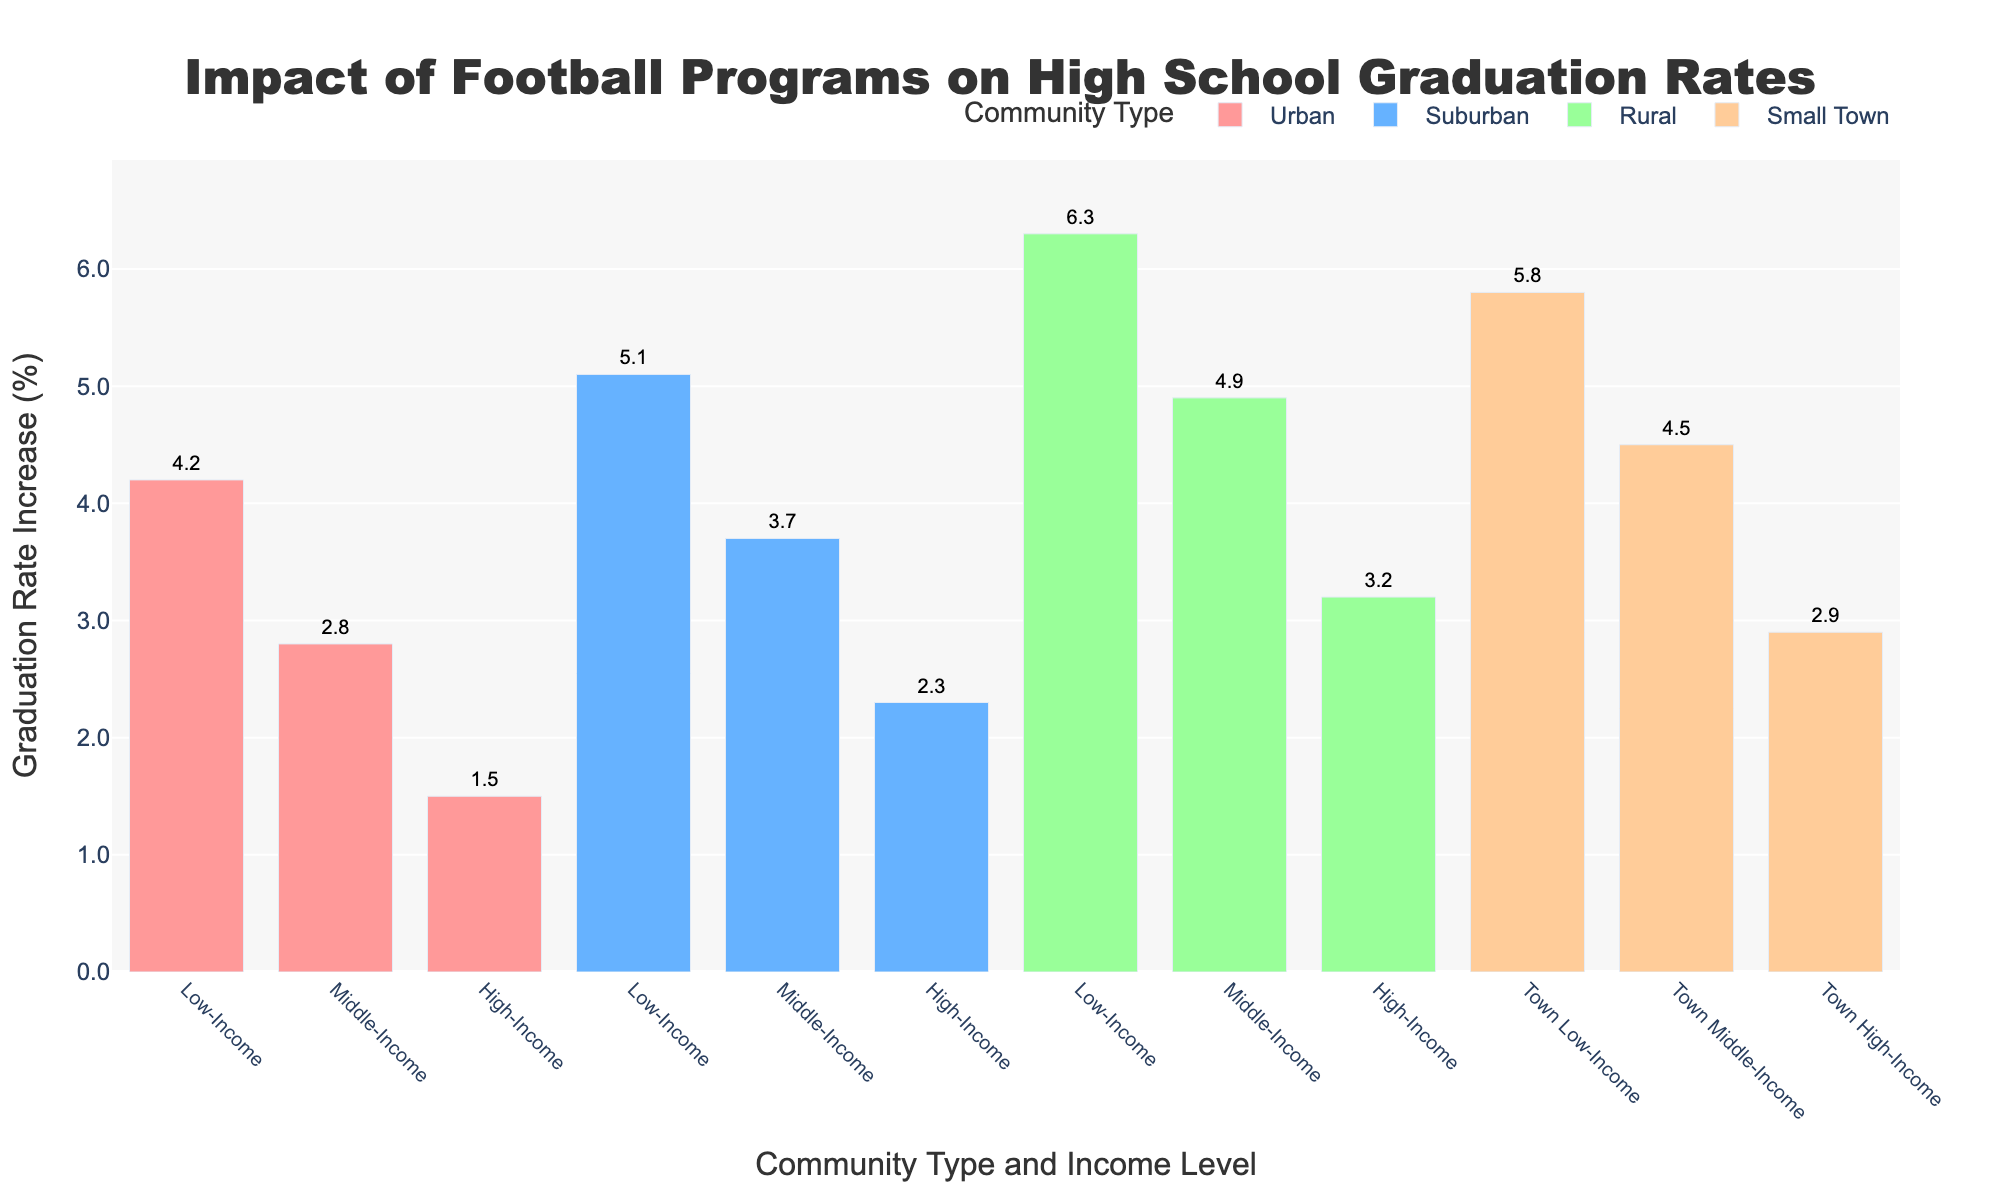Which community type has the highest increase in graduation rates for low-income groups? To determine the highest increase, look at the bar heights for "Low-Income" across all community types. The bar for "Rural Low-Income" is the tallest among the low-income groups.
Answer: Rural What's the difference in graduation rate increase between "Urban Low-Income" and "Urban High-Income" communities? Identify the bars for "Urban Low-Income" and "Urban High-Income". Subtract the graduation rate increase of "Urban High-Income" (1.5%) from "Urban Low-Income" (4.2%). 4.2% - 1.5% = 2.7%.
Answer: 2.7% Among "Rural", "Suburban", and "Urban" middle-income communities, which has the smallest graduation rate increase? Compare the bars for "Middle-Income" in "Rural," "Suburban," and "Urban". "Urban Middle-Income" has the smallest increase (2.8%).
Answer: Urban Middle-Income What is the average graduation rate increase for all communities classified as "High-Income"? Add the graduation rate increases for all "High-Income" communities: Urban (1.5%), Suburban (2.3%), Rural (3.2%), Small Town (2.9%). Divide by the number of high-income communities (4). 
(1.5% + 2.3% + 3.2% + 2.9%) / 4 = 9.9% / 4 = 2.475%.
Answer: 2.5% Does the "Small Town Low-Income" have a higher graduation rate increase than "Suburban Middle-Income"? Compare the bars for "Small Town Low-Income" (5.8%) and "Suburban Middle-Income" (3.7%). Small Town Low-Income is higher.
Answer: Yes Which community type, regardless of income, generally shows the highest graduation rate increase? Compare the heights of the bars across all community types. "Rural" community bars generally show the highest graduation rate increases.
Answer: Rural What is the total graduation rate increase for all "Low-Income" communities combined? Add the graduation rate increases for all "Low-Income" communities: Urban (4.2%), Suburban (5.1%), Rural (6.3%), Small Town (5.8%).
4.2% + 5.1% + 6.3% + 5.8% = 21.4%.
Answer: 21.4% Which bar color represents suburban communities? Identify the color assigned to each community type: Suburban bars are colored blue.
Answer: Blue Which income group within "Suburban" communities has the highest graduation rate increase? Look at "Suburban" bar heights and compare "Low-Income" (5.1%), "Middle-Income" (3.7%), and "High-Income" (2.3%). "Suburban Low-Income" has the highest increase.
Answer: Low-Income What community type and income level combination has the smallest increase in graduation rates? Identify the shortest bar on the chart. The "Urban High-Income" bar is the shortest, indicating the smallest increase, which is 1.5%.
Answer: Urban High-Income 